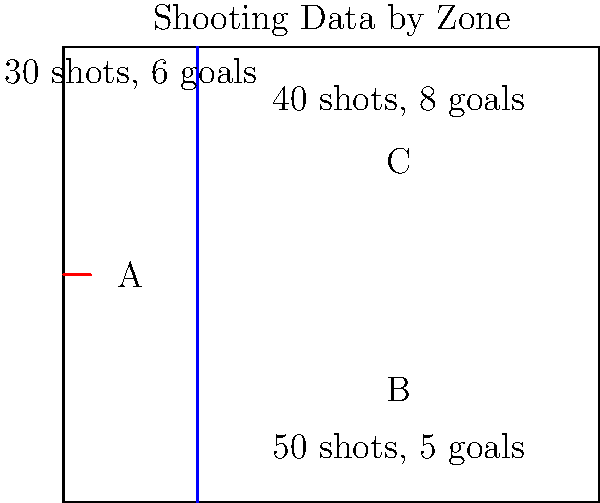Based on the shooting data provided for each zone in the offensive half of the ice, which zone has the highest shooting percentage, and what is that percentage? To solve this problem, we need to calculate the shooting percentage for each zone and compare them. The shooting percentage is calculated by dividing the number of goals by the number of shots and multiplying by 100.

Let's calculate the shooting percentage for each zone:

Zone A:
- Shots: 30
- Goals: 6
- Shooting percentage = (6 / 30) * 100 = 20%

Zone B:
- Shots: 50
- Goals: 5
- Shooting percentage = (5 / 50) * 100 = 10%

Zone C:
- Shots: 40
- Goals: 8
- Shooting percentage = (8 / 40) * 100 = 20%

Comparing the percentages:
Zone A: 20%
Zone B: 10%
Zone C: 20%

We can see that both Zone A and Zone C have the highest shooting percentage at 20%.

To determine which zone to choose, we need to consider the number of shots taken. Zone C had more shots (40) compared to Zone A (30), which makes it a more reliable statistic. Therefore, we'll choose Zone C as the answer.
Answer: Zone C, 20% 